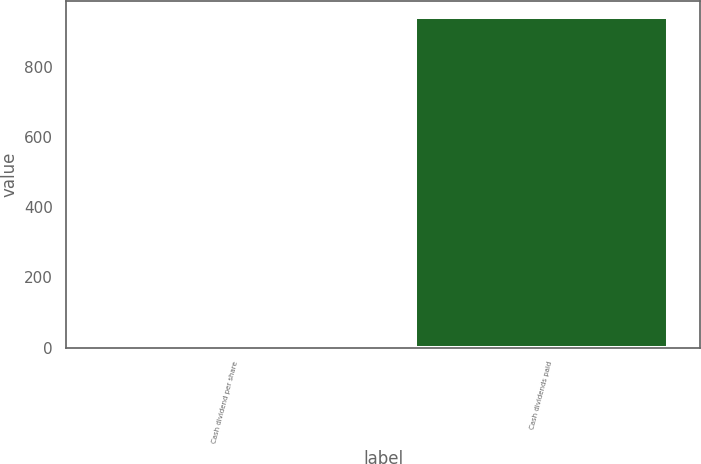Convert chart to OTSL. <chart><loc_0><loc_0><loc_500><loc_500><bar_chart><fcel>Cash dividend per share<fcel>Cash dividends paid<nl><fcel>0.88<fcel>942<nl></chart> 